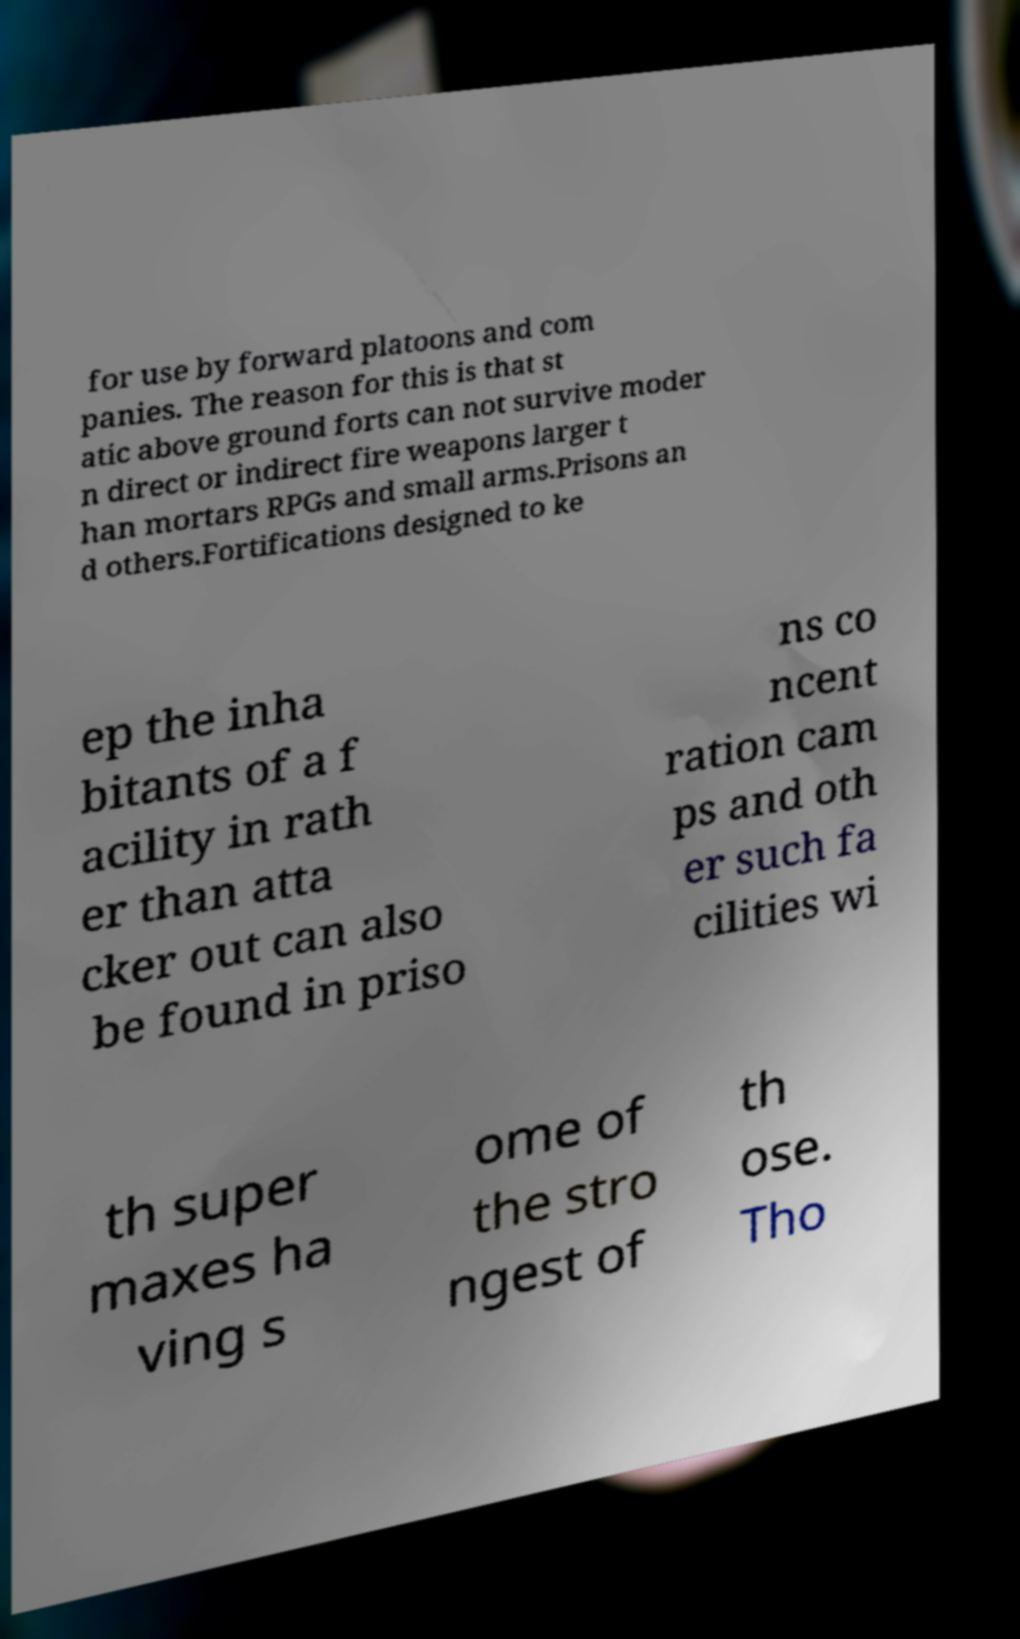There's text embedded in this image that I need extracted. Can you transcribe it verbatim? for use by forward platoons and com panies. The reason for this is that st atic above ground forts can not survive moder n direct or indirect fire weapons larger t han mortars RPGs and small arms.Prisons an d others.Fortifications designed to ke ep the inha bitants of a f acility in rath er than atta cker out can also be found in priso ns co ncent ration cam ps and oth er such fa cilities wi th super maxes ha ving s ome of the stro ngest of th ose. Tho 